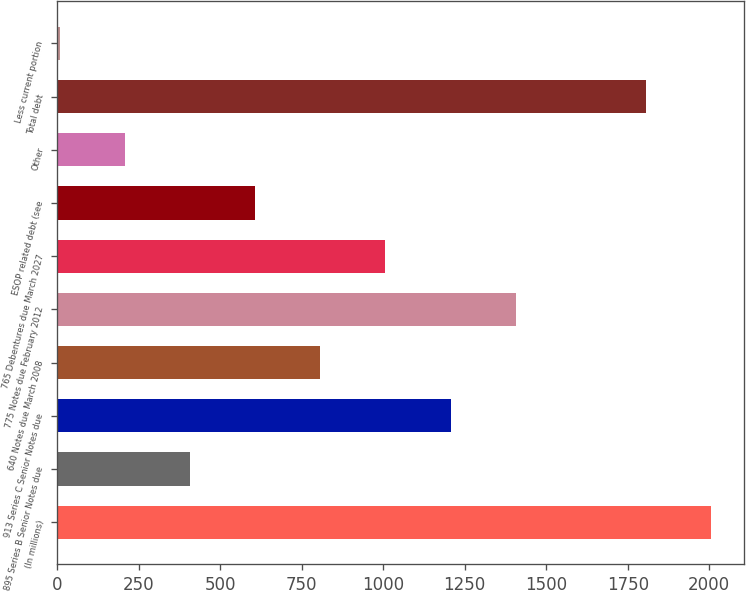Convert chart to OTSL. <chart><loc_0><loc_0><loc_500><loc_500><bar_chart><fcel>(In millions)<fcel>895 Series B Senior Notes due<fcel>913 Series C Senior Notes due<fcel>640 Notes due March 2008<fcel>775 Notes due February 2012<fcel>765 Debentures due March 2027<fcel>ESOP related debt (see<fcel>Other<fcel>Total debt<fcel>Less current portion<nl><fcel>2005<fcel>408.2<fcel>1206.6<fcel>807.4<fcel>1406.2<fcel>1007<fcel>607.8<fcel>208.6<fcel>1805.4<fcel>9<nl></chart> 